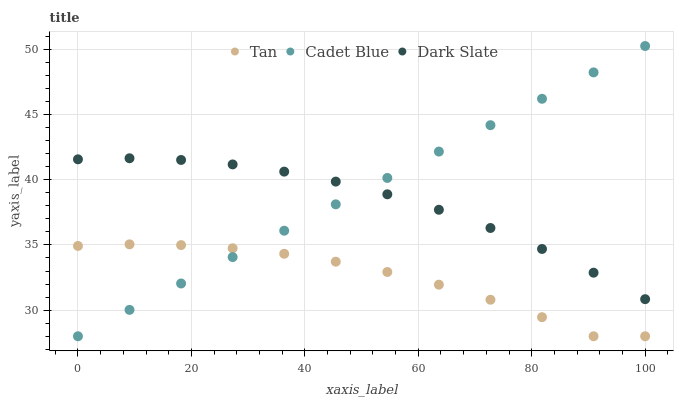Does Tan have the minimum area under the curve?
Answer yes or no. Yes. Does Cadet Blue have the maximum area under the curve?
Answer yes or no. Yes. Does Cadet Blue have the minimum area under the curve?
Answer yes or no. No. Does Tan have the maximum area under the curve?
Answer yes or no. No. Is Cadet Blue the smoothest?
Answer yes or no. Yes. Is Tan the roughest?
Answer yes or no. Yes. Is Tan the smoothest?
Answer yes or no. No. Is Cadet Blue the roughest?
Answer yes or no. No. Does Tan have the lowest value?
Answer yes or no. Yes. Does Cadet Blue have the highest value?
Answer yes or no. Yes. Does Tan have the highest value?
Answer yes or no. No. Is Tan less than Dark Slate?
Answer yes or no. Yes. Is Dark Slate greater than Tan?
Answer yes or no. Yes. Does Dark Slate intersect Cadet Blue?
Answer yes or no. Yes. Is Dark Slate less than Cadet Blue?
Answer yes or no. No. Is Dark Slate greater than Cadet Blue?
Answer yes or no. No. Does Tan intersect Dark Slate?
Answer yes or no. No. 